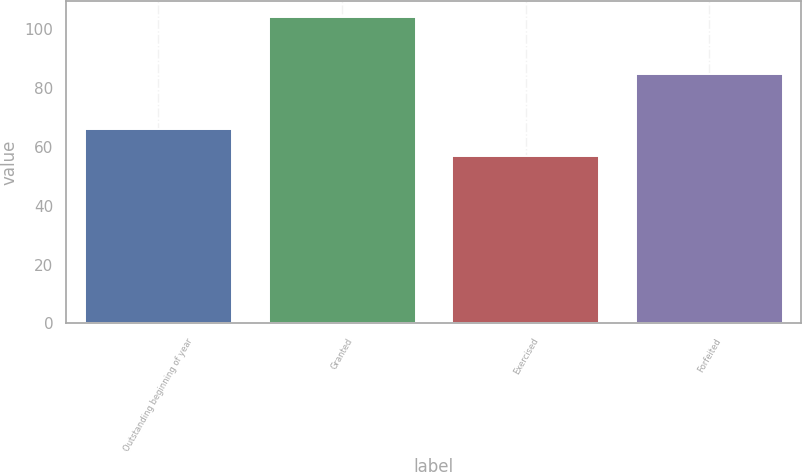Convert chart. <chart><loc_0><loc_0><loc_500><loc_500><bar_chart><fcel>Outstanding beginning of year<fcel>Granted<fcel>Exercised<fcel>Forfeited<nl><fcel>66.08<fcel>104.23<fcel>56.95<fcel>84.6<nl></chart> 